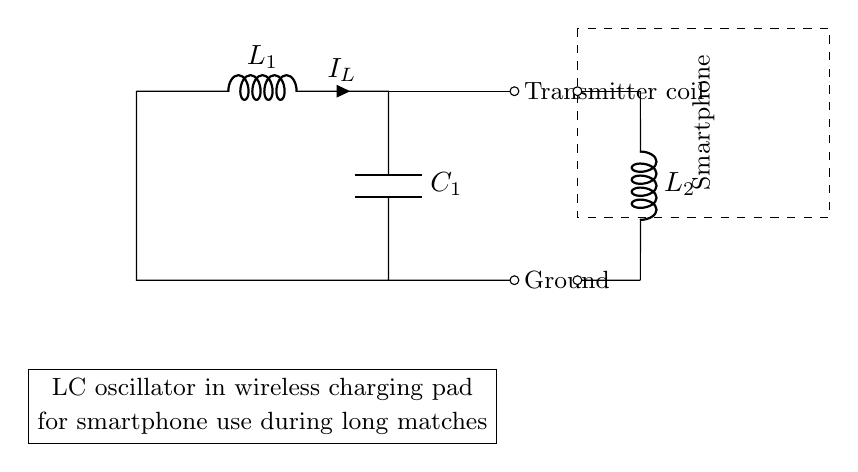What component is represented by L1? L1 represents an inductor in the circuit. It is designated by the letter "L" in the circuit diagram.
Answer: Inductor What is the function of C1 in this circuit? C1 is a capacitor. In this circuit, it stores electrical energy and contributes to the circuit's oscillation characteristics.
Answer: Stores energy How many coils are depicted in this diagram? There are two coils in the diagram: L1 and L2. Each coil contributes to the inductive parameters of the circuit.
Answer: Two What is the purpose of the dashed rectangle in the circuit? The dashed rectangle indicates the area where the smartphone is located, which is the intended recipient of the wireless charging.
Answer: Smartphone Explain the relationship between the inductors in this circuit. L1 and L2 indicate that they are both inductors in the circuit, which implies their arrangement is involved in generating oscillations for wireless transmission. Their collective behavior affects the oscillation frequency.
Answer: Generates oscillations What type of circuit is this diagram illustrating? The diagram is illustrating an LC oscillator circuit, which is specifically designed for oscillation and resonance using inductors and capacitors.
Answer: LC oscillator What happens to the energy in the capacitor during oscillation? During oscillation, the energy in the capacitor is converted back and forth to energy in the inductor, allowing for continuous oscillation until energy is lost.
Answer: Energy conversion 